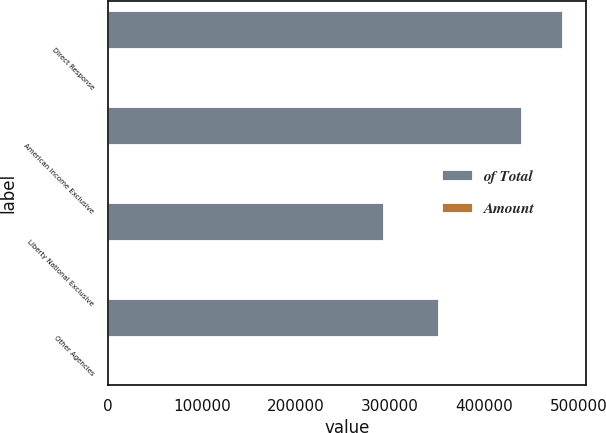Convert chart. <chart><loc_0><loc_0><loc_500><loc_500><stacked_bar_chart><ecel><fcel>Direct Response<fcel>American Income Exclusive<fcel>Liberty National Exclusive<fcel>Other Agencies<nl><fcel>of Total<fcel>484176<fcel>440164<fcel>293936<fcel>351688<nl><fcel>Amount<fcel>31<fcel>28<fcel>19<fcel>22<nl></chart> 